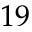<formula> <loc_0><loc_0><loc_500><loc_500>1 9</formula> 